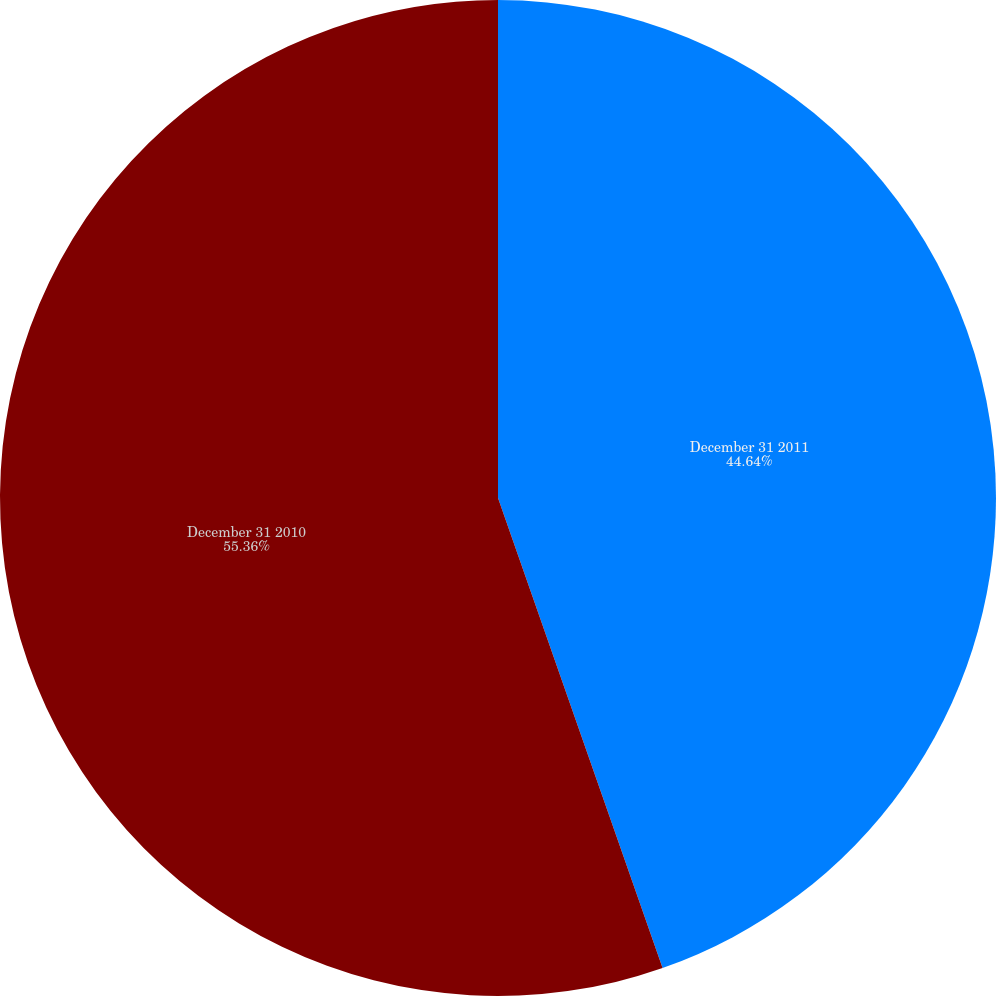<chart> <loc_0><loc_0><loc_500><loc_500><pie_chart><fcel>December 31 2011<fcel>December 31 2010<nl><fcel>44.64%<fcel>55.36%<nl></chart> 